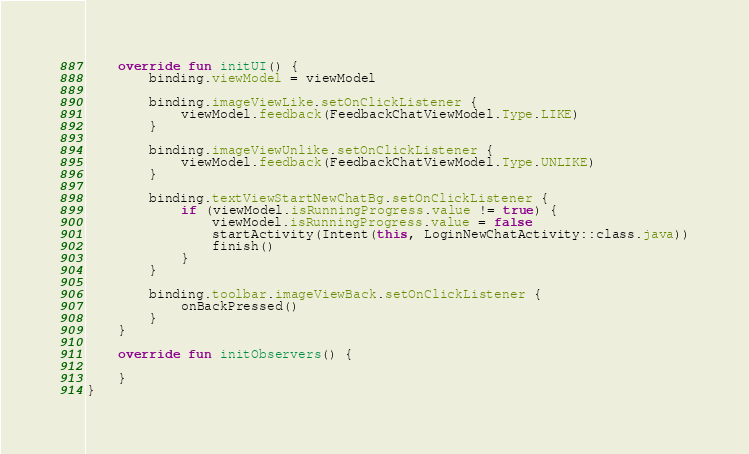Convert code to text. <code><loc_0><loc_0><loc_500><loc_500><_Kotlin_>    override fun initUI() {
        binding.viewModel = viewModel

        binding.imageViewLike.setOnClickListener {
            viewModel.feedback(FeedbackChatViewModel.Type.LIKE)
        }

        binding.imageViewUnlike.setOnClickListener {
            viewModel.feedback(FeedbackChatViewModel.Type.UNLIKE)
        }

        binding.textViewStartNewChatBg.setOnClickListener {
            if (viewModel.isRunningProgress.value != true) {
                viewModel.isRunningProgress.value = false
                startActivity(Intent(this, LoginNewChatActivity::class.java))
                finish()
            }
        }

        binding.toolbar.imageViewBack.setOnClickListener {
            onBackPressed()
        }
    }

    override fun initObservers() {

    }
}</code> 